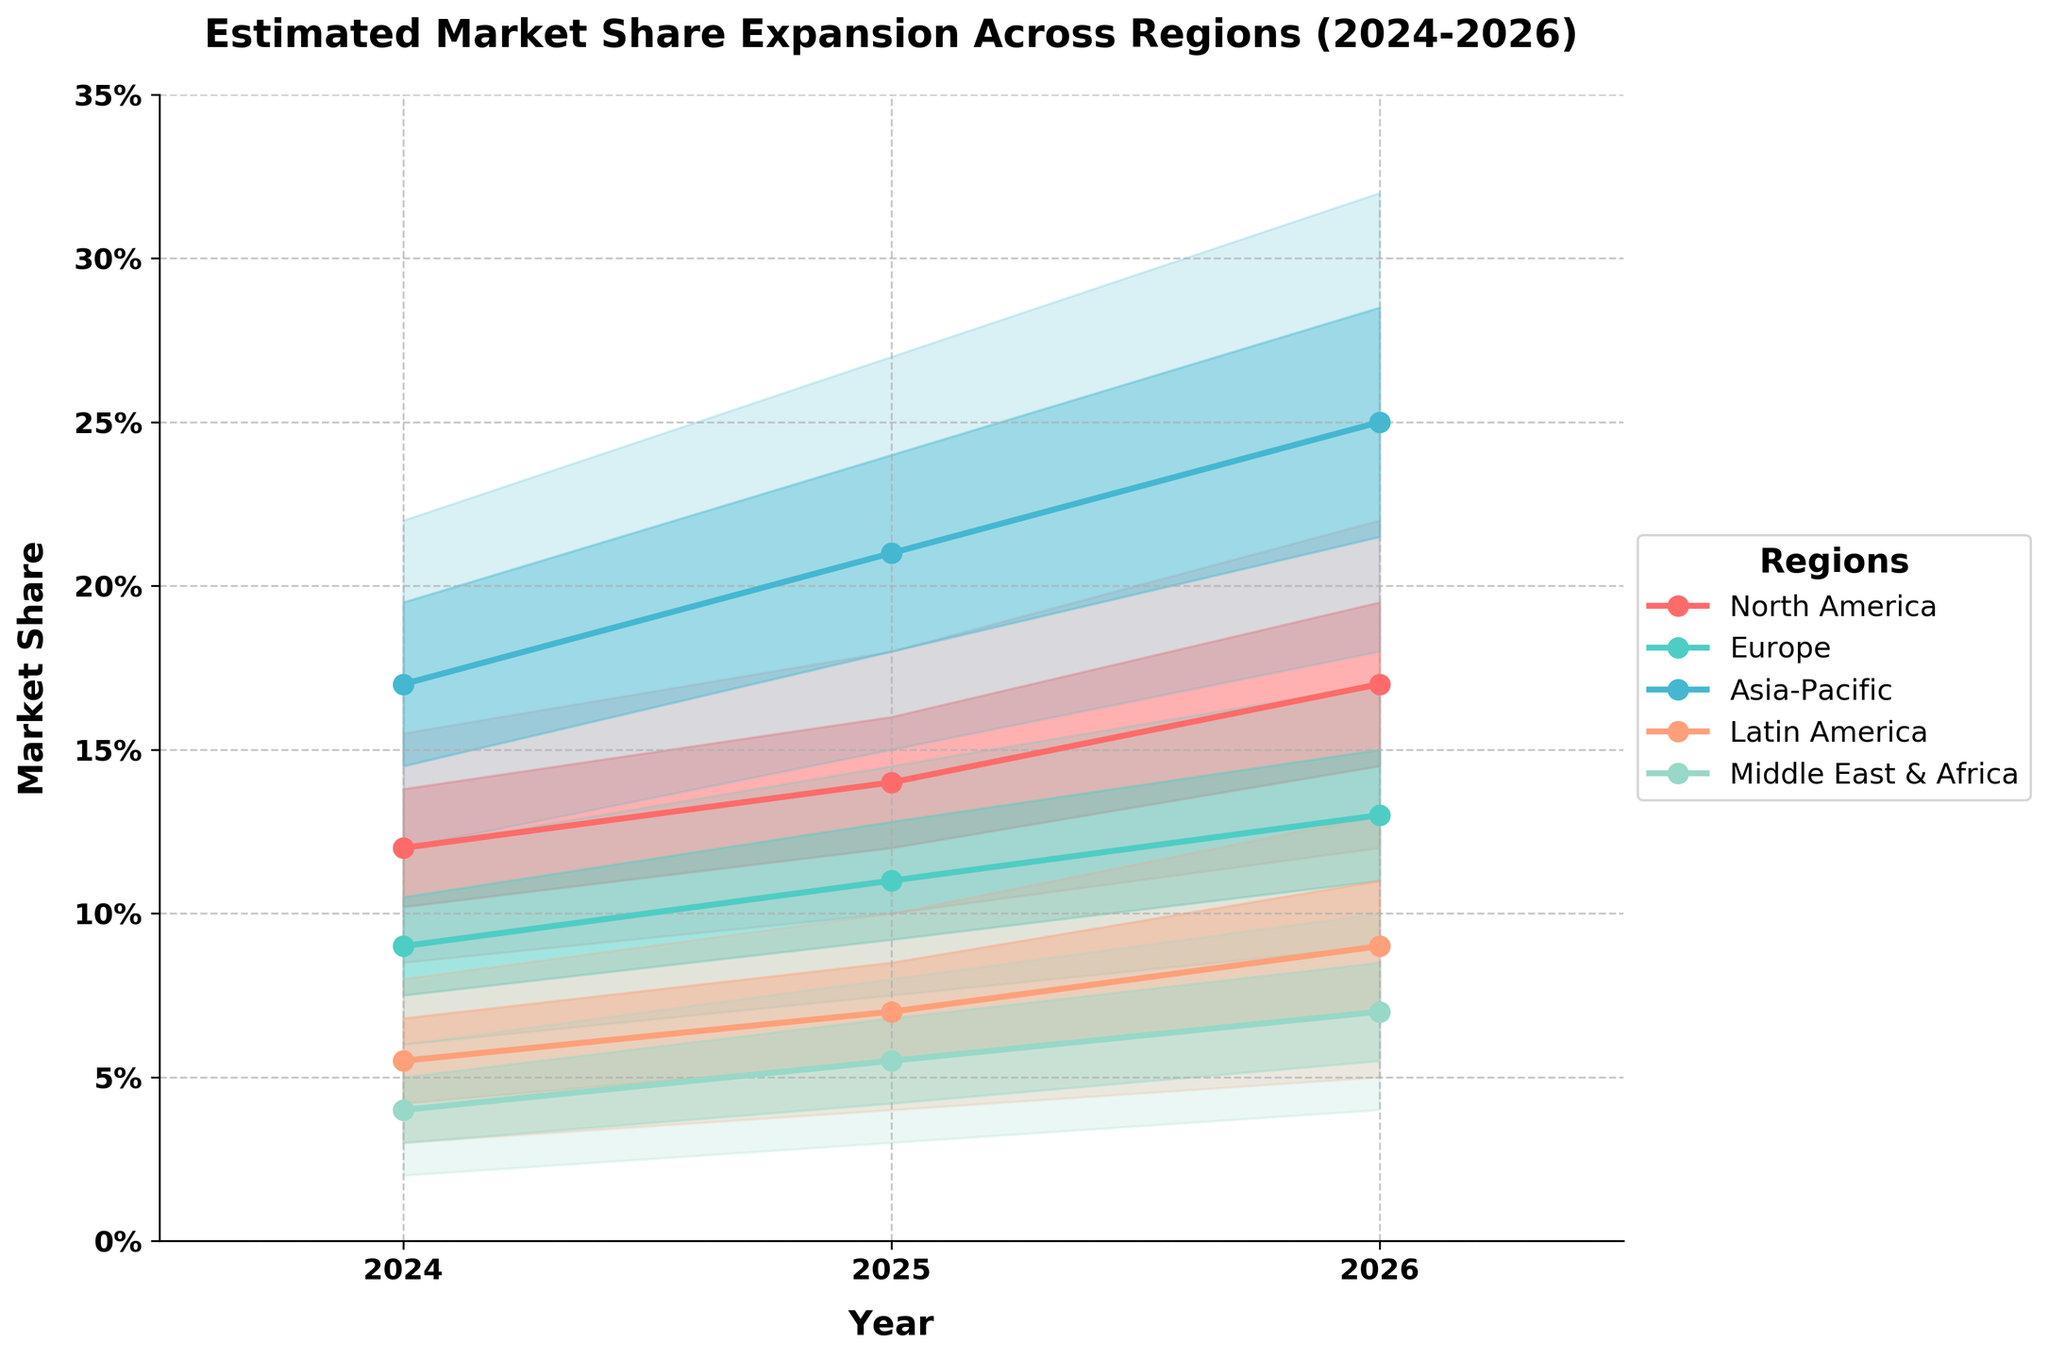What is the title of the figure? The title is a direct text element present at the top of the figure.
Answer: Estimated Market Share Expansion Across Regions (2024-2026) Which region shows the highest mid estimate for market share in 2026? From the plot, we can see that the Asia-Pacific region has the highest mid estimate in 2026, with a mid estimate line peaking higher than any other region's mid estimate.
Answer: Asia-Pacific How does the estimated market share for Europe change from 2024 to 2026? By tracking the mid estimate line for Europe in the figure from 2024 to 2026, we observe that it climbs from around 9% to around 13%.
Answer: It increases by 4% Which region shows the widest range of estimates in 2025? By comparing the spread between the low and high estimates for each region in 2025, the Asia-Pacific region has the widest range, going from 15% to 27%, a spread of 12%.
Answer: Asia-Pacific What is the mid-high estimate for North America in 2025? Locate the mid-high estimate line for North America in the year 2025. The value is marked on the y-axis around 16%.
Answer: 16.0% Which regions have the lowest estimates consistently across the three years? By observing the lowest bounds of the fan chart across 2024, 2025, and 2026, the Middle East & Africa show the lowest estimates consistently.
Answer: Middle East & Africa How do North America's and Europe's mid estimates in 2026 compare? Comparing the mid estimate lines for North America and Europe in 2026, North America's mid estimate is higher, standing at about 17% compared to Europe’s 13%.
Answer: North America is higher by 4% What is the trend in the estimated market share for Latin America from 2024 to 2026? Tracking the mid estimate lines from 2024 to 2026, we see that the Latin America's mid estimate increases from about 5.5% to about 9%.
Answer: It increases by 3.5% Which region shows the smallest increase in their mid estimate from 2024 to 2026? By calculating the increase in mid estimates for each region from 2024 to 2026, the Middle East & Africa shows the smallest increase, from 4.0% to 7.0% (3%).
Answer: Middle East & Africa What is the high estimate for Asia-Pacific in 2026? Locate the high estimate line for Asia-Pacific in 2026 and observe its value on the y-axis. It peaks around 32%.
Answer: 32.0% 